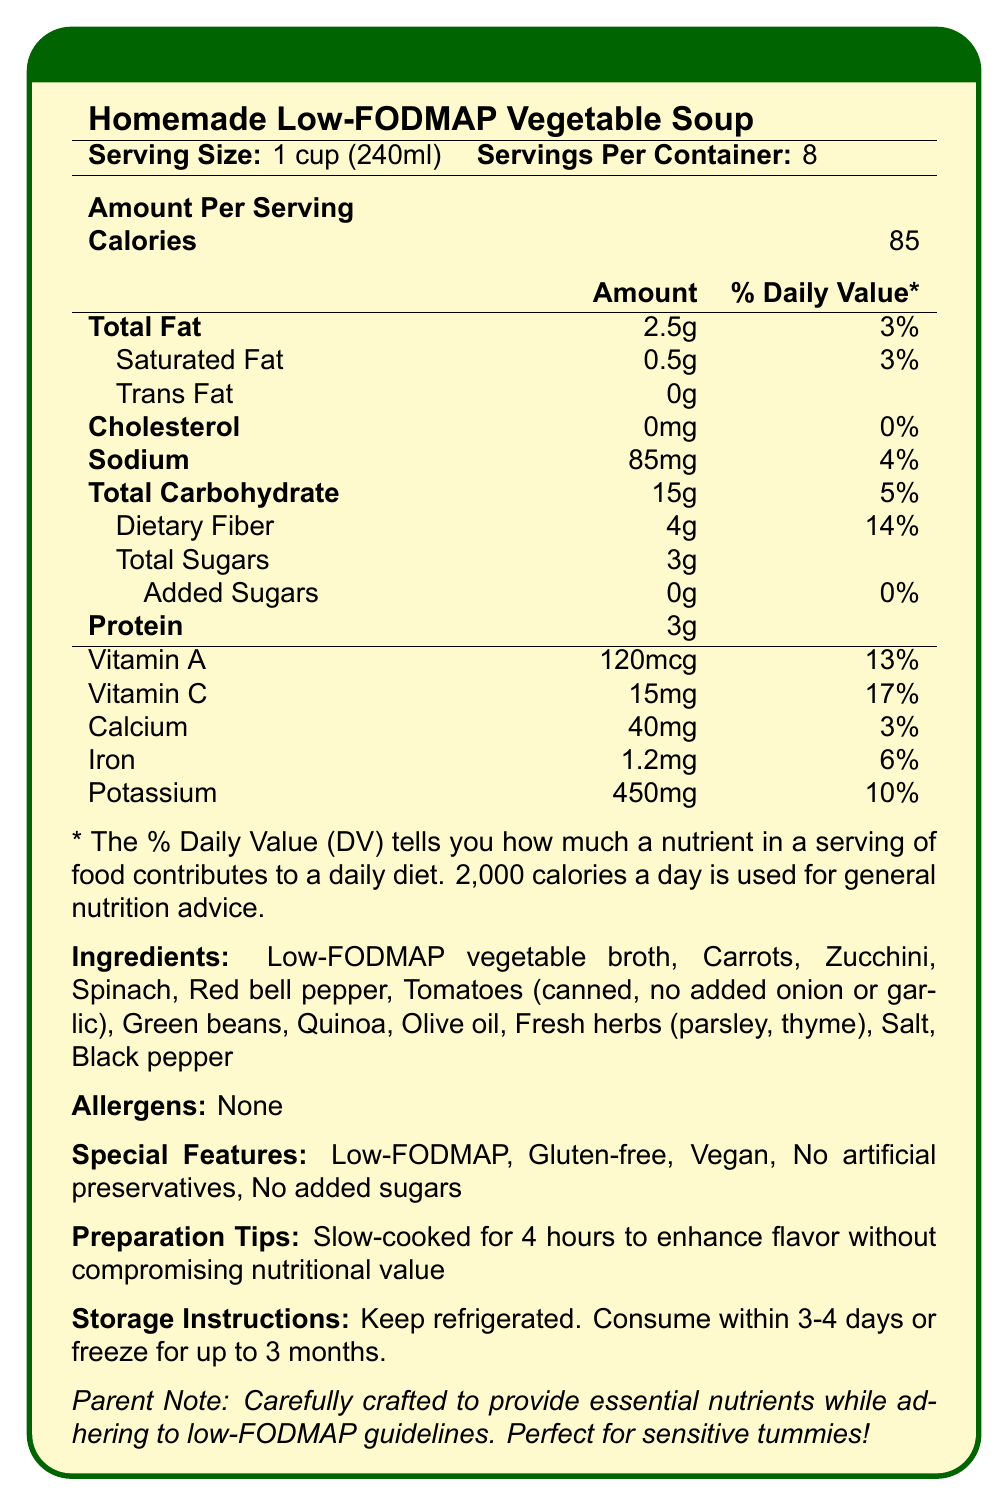what is the serving size of the Homemade Low-FODMAP Vegetable Soup? The serving size is clearly stated at the beginning of the nutrition facts section.
Answer: 1 cup (240ml) how many calories are in one serving of the soup? The calories per serving are listed immediately under the serving size.
Answer: 85 what is the percentage daily value of dietary fiber in one serving? The percentage daily value of dietary fiber is listed as 14% in the table.
Answer: 14% how much sodium is in one serving of the soup? The sodium content per serving is clearly listed in the nutritional information.
Answer: 85mg how much total fat is in one serving of the soup? The amount of total fat is listed under the nutrition facts.
Answer: 2.5g how many servings are there per container of the soup? The number of servings per container is mentioned at the top of the nutrition facts section.
Answer: 8 which of the following special features does the soup have? A. High-FODMAP B. Contains Gluten C. Vegan D. Contains Artificial Preservatives The soup is labeled as "Vegan" in the special features section.
Answer: C what are the primary ingredients in the soup? The ingredients are listed clearly at the bottom of the nutrition facts section.
Answer: Low-FODMAP vegetable broth, Carrots, Zucchini, Spinach, Red bell pepper, Tomatoes (canned, no added onion or garlic), Green beans, Quinoa, Olive oil, Fresh herbs (parsley, thyme), Salt, Black pepper does the soup contain any allergens? The allergens section specifies that the soup contains none.
Answer: No what is the amount of potassium in one serving? The amount of potassium is listed under the nutrition facts.
Answer: 450mg is there any added sugar in the soup? A. Yes B. No C. Not Stated The nutrition facts state that there are 0g of added sugars.
Answer: B how many grams of protein are in one serving? The protein content is listed under the nutrition facts.
Answer: 3g how should the soup be stored? The storage instructions are provided at the end of the document.
Answer: Keep refrigerated. Consume within 3-4 days or freeze for up to 3 months. is this soup suitable for people with gluten intolerance? The special features state that the soup is gluten-free.
Answer: Yes describe the primary nutritional characteristics of the Homemade Low-FODMAP Vegetable Soup. The description involves summarizing the key nutritional highlights and special features of the soup.
Answer: The soup is low in sodium and high in dietary fiber, providing essential nutrients without any allergens. It is also low-FODMAP, gluten-free, vegan, and free from artificial preservatives and added sugars. what is the sodium to fiber ratio per serving of the soup? The sodium content per serving is 85mg, and the dietary fiber content is 4g. Hence, the ratio is 85mg of sodium to 4g of fiber.
Answer: 85mg sodium to 4g fiber how long should the soup be slow-cooked? The preparation tips mention that the soup should be slow-cooked for 4 hours to enhance flavor.
Answer: 4 hours does the soup contain tomatoes? Tomatoes (canned, no added onion or garlic) are listed as one of the ingredients.
Answer: Yes what are the daily values percentage of Calcium and Iron together in one serving? Calcium has a daily value of 3% and Iron has a daily value of 6%. Together, they sum up to 9%.
Answer: 9% does the soup have any cholesterol? The nutrition facts state that the cholesterol content is 0mg, corresponding to 0% Daily Value.
Answer: No what are the low-FODMAP vegetables included in the soup? These vegetables are listed as ingredients and are known to be low-FODMAP.
Answer: Carrots, Zucchini, Spinach, Red bell pepper, Green beans what is the flavor enhancement strategy mentioned in the document? The preparation tips indicate slow-cooking for 4 hours to enhance the flavor.
Answer: Slow-cooked for 4 hours are there any artificial preservatives in the soup? The special features mention "No artificial preservatives."
Answer: No how many grams of total Sugars are in one serving? The nutrition facts list 3g of total sugars per serving.
Answer: 3g what are the major vitamins provided by the soup and their daily values? The nutrition facts list Vitamin A at 120mcg (13% DV) and Vitamin C at 15mg (17% DV).
Answer: Vitamin A (13%), Vitamin C (17%) does the document mention if the soup is organic? There is no mention of the soup being organic in the document.
Answer: No 